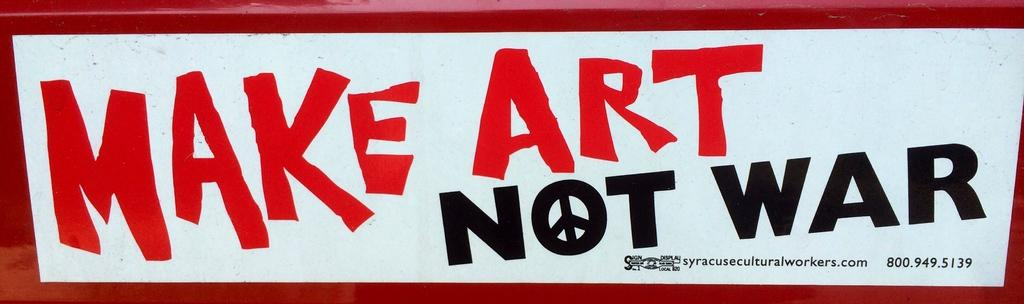<image>
Relay a brief, clear account of the picture shown. A bumper sticker that says make art not war. 